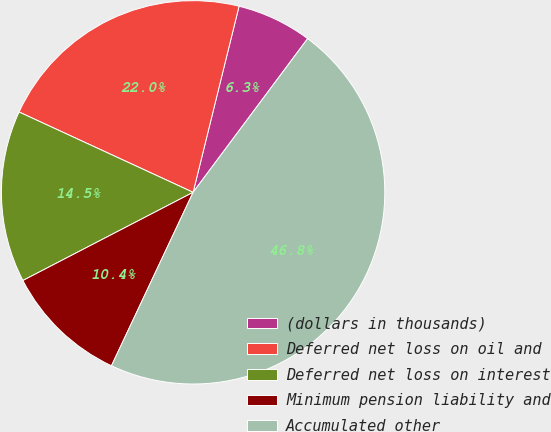Convert chart to OTSL. <chart><loc_0><loc_0><loc_500><loc_500><pie_chart><fcel>(dollars in thousands)<fcel>Deferred net loss on oil and<fcel>Deferred net loss on interest<fcel>Minimum pension liability and<fcel>Accumulated other<nl><fcel>6.34%<fcel>21.97%<fcel>14.49%<fcel>10.39%<fcel>46.81%<nl></chart> 